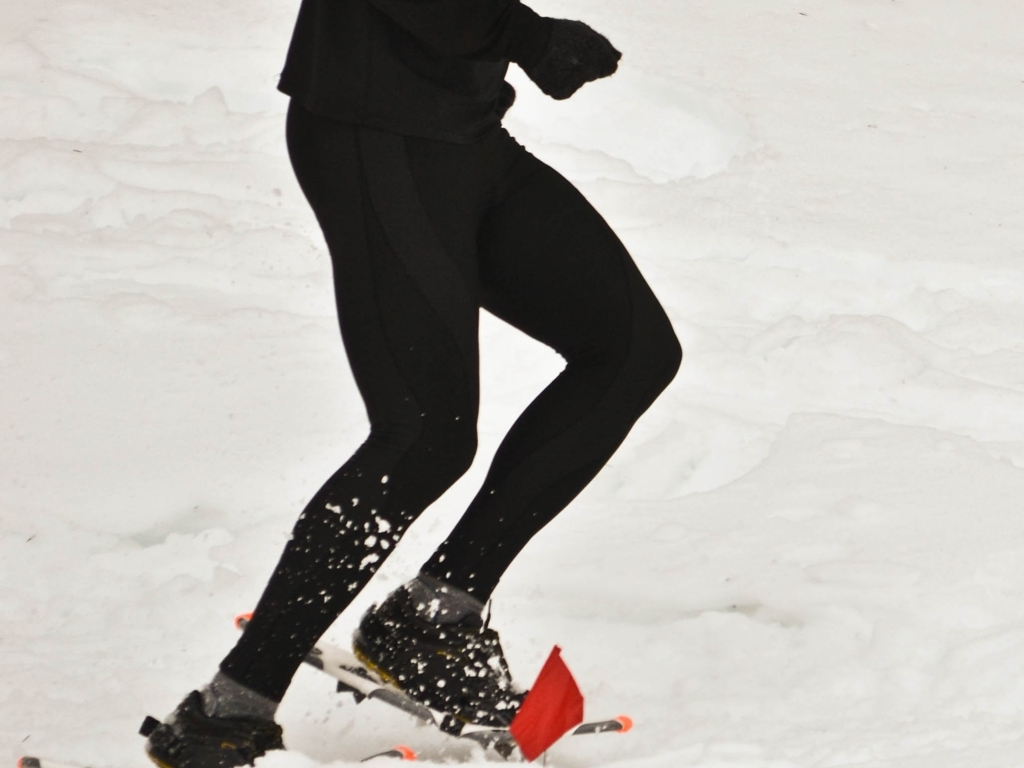What is the condition of the overall composition? The composition of the image shows a dynamic scene captured with moderate clarity. The subject, a person engaged in a winter running activity, is in focus, suggesting movement amid snowy conditions. The lighting appears natural and diffused, likely due to overcast weather, providing even illumination across the scene. While the background is less detailed, lacking contrast or distinctive features, the composition effectively conveys the essence of outdoor winter exercise. 